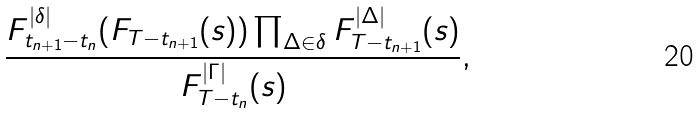Convert formula to latex. <formula><loc_0><loc_0><loc_500><loc_500>\frac { F _ { t _ { n + 1 } - t _ { n } } ^ { | \delta | } ( F _ { T - t _ { n + 1 } } ( s ) ) \prod _ { \Delta \in \delta } F _ { T - t _ { n + 1 } } ^ { | \Delta | } ( s ) } { F _ { T - t _ { n } } ^ { | \Gamma | } ( s ) } ,</formula> 